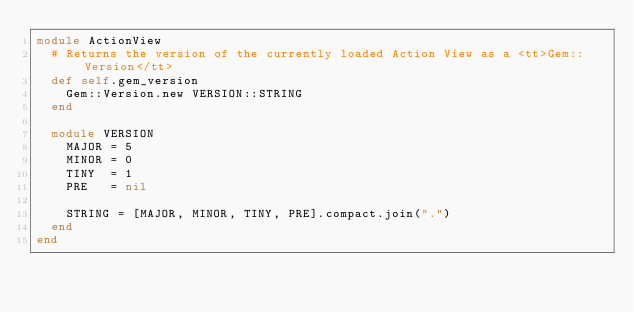<code> <loc_0><loc_0><loc_500><loc_500><_Ruby_>module ActionView
  # Returns the version of the currently loaded Action View as a <tt>Gem::Version</tt>
  def self.gem_version
    Gem::Version.new VERSION::STRING
  end

  module VERSION
    MAJOR = 5
    MINOR = 0
    TINY  = 1
    PRE   = nil

    STRING = [MAJOR, MINOR, TINY, PRE].compact.join(".")
  end
end
</code> 